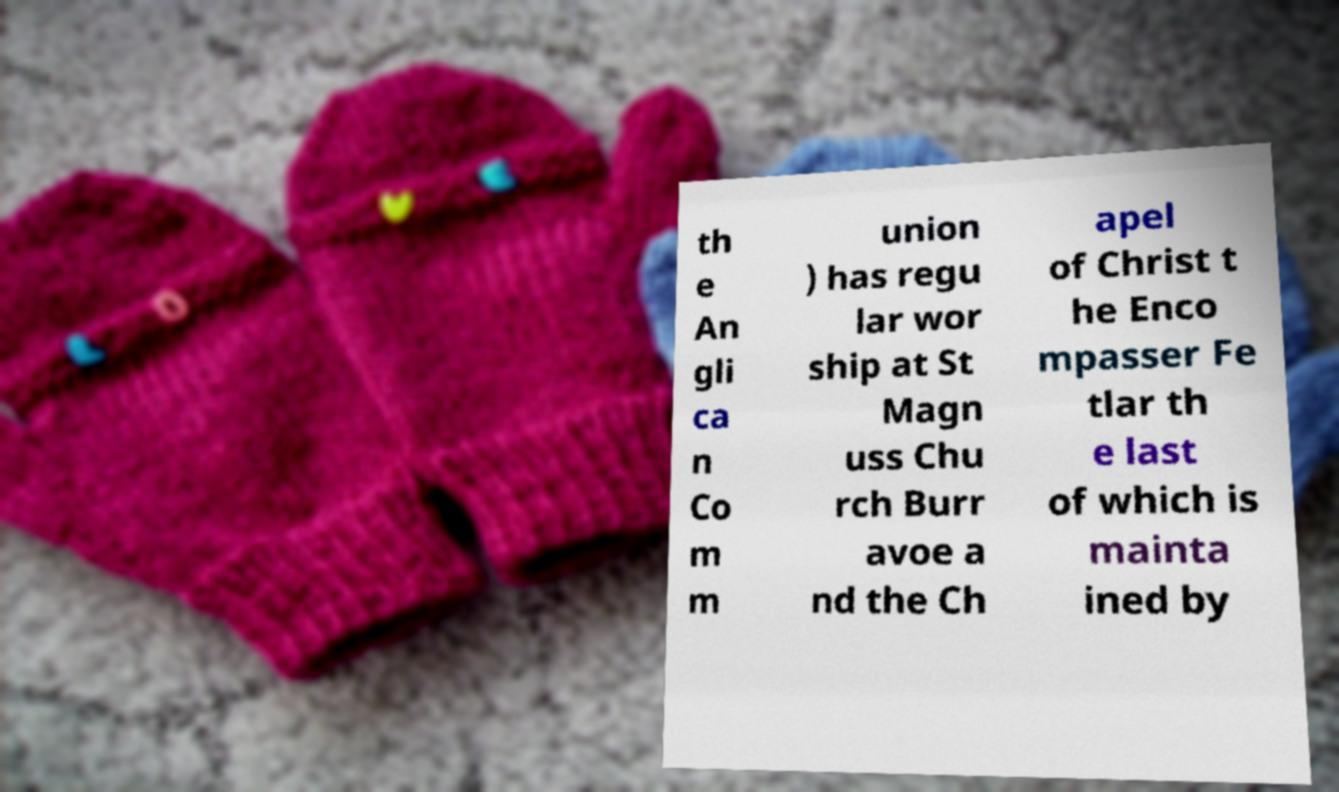I need the written content from this picture converted into text. Can you do that? th e An gli ca n Co m m union ) has regu lar wor ship at St Magn uss Chu rch Burr avoe a nd the Ch apel of Christ t he Enco mpasser Fe tlar th e last of which is mainta ined by 